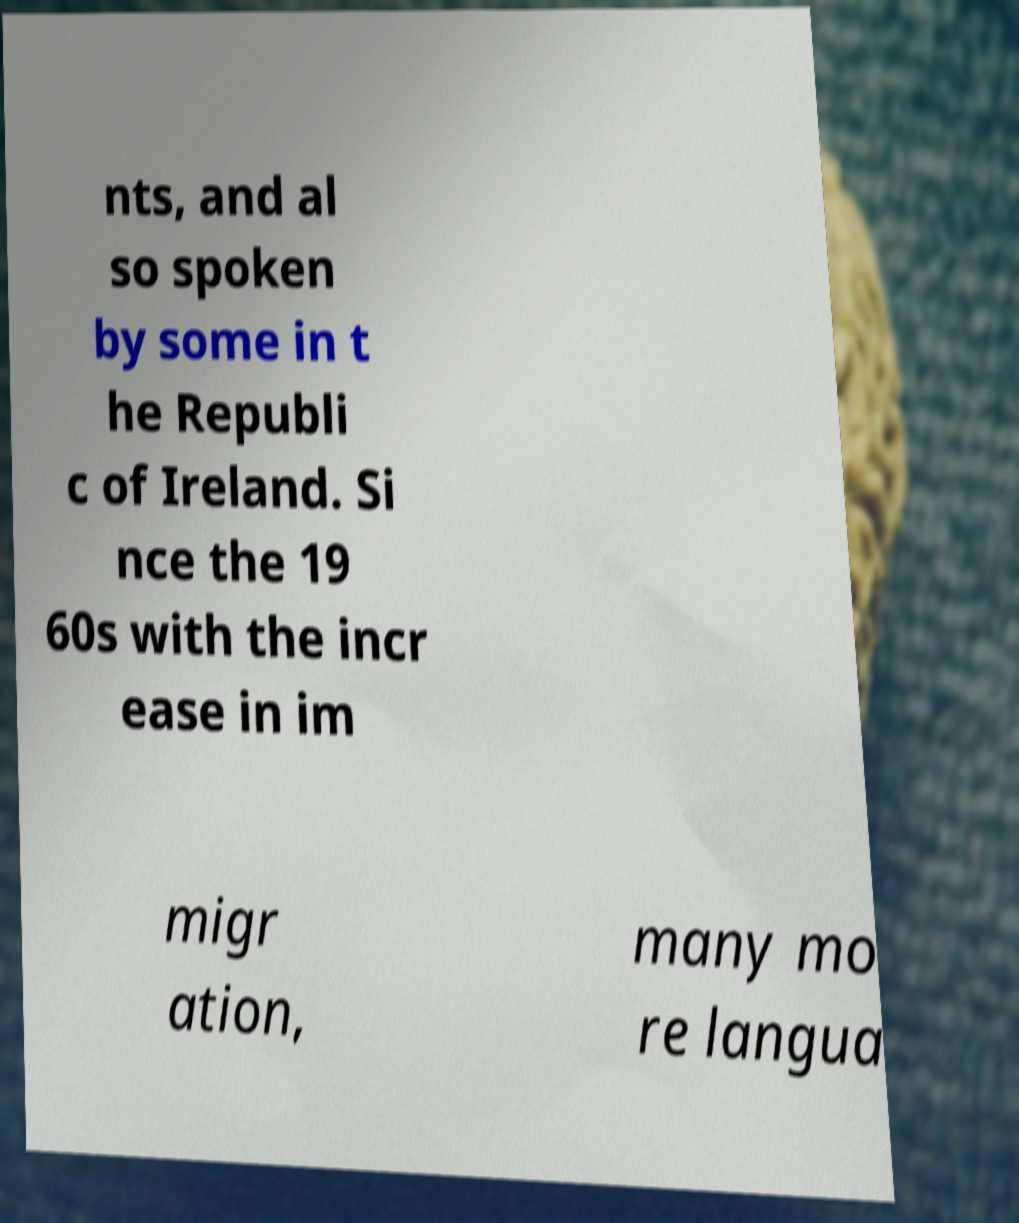What messages or text are displayed in this image? I need them in a readable, typed format. nts, and al so spoken by some in t he Republi c of Ireland. Si nce the 19 60s with the incr ease in im migr ation, many mo re langua 